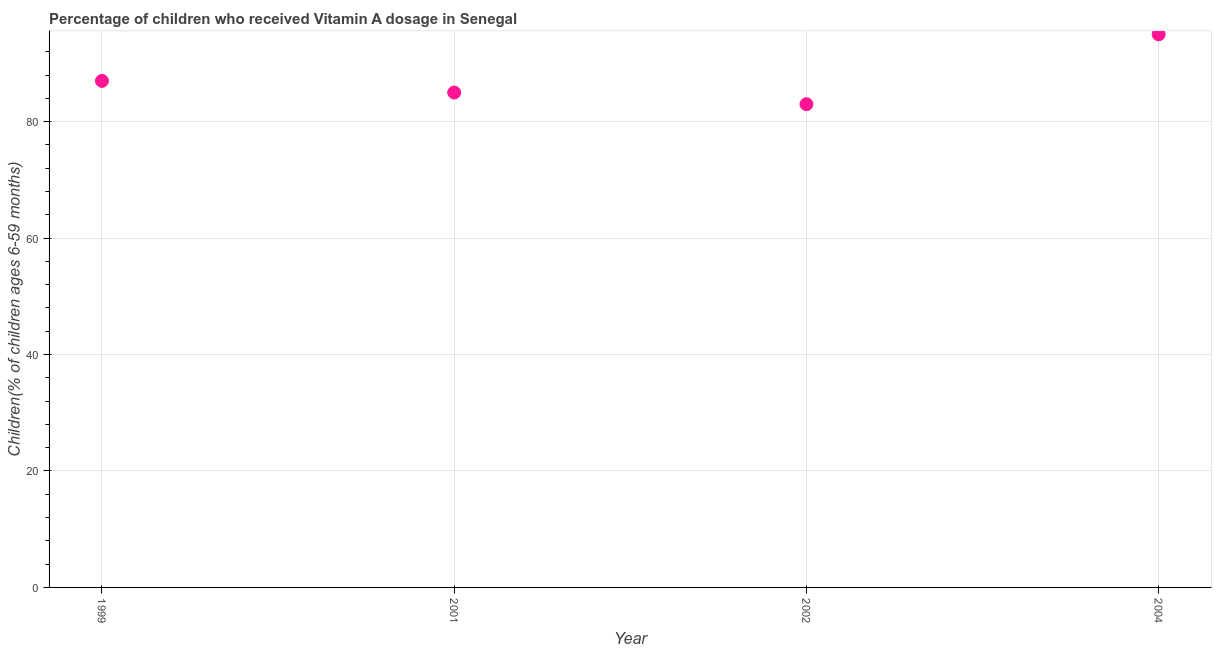What is the vitamin a supplementation coverage rate in 2001?
Make the answer very short. 85. Across all years, what is the maximum vitamin a supplementation coverage rate?
Ensure brevity in your answer.  95. Across all years, what is the minimum vitamin a supplementation coverage rate?
Give a very brief answer. 83. In which year was the vitamin a supplementation coverage rate maximum?
Provide a short and direct response. 2004. In which year was the vitamin a supplementation coverage rate minimum?
Your answer should be compact. 2002. What is the sum of the vitamin a supplementation coverage rate?
Give a very brief answer. 350. What is the difference between the vitamin a supplementation coverage rate in 2001 and 2004?
Offer a terse response. -10. What is the average vitamin a supplementation coverage rate per year?
Keep it short and to the point. 87.5. In how many years, is the vitamin a supplementation coverage rate greater than 76 %?
Offer a very short reply. 4. Do a majority of the years between 2004 and 2002 (inclusive) have vitamin a supplementation coverage rate greater than 84 %?
Ensure brevity in your answer.  No. What is the ratio of the vitamin a supplementation coverage rate in 1999 to that in 2004?
Your answer should be very brief. 0.92. What is the difference between the highest and the second highest vitamin a supplementation coverage rate?
Your response must be concise. 8. What is the difference between the highest and the lowest vitamin a supplementation coverage rate?
Your answer should be compact. 12. In how many years, is the vitamin a supplementation coverage rate greater than the average vitamin a supplementation coverage rate taken over all years?
Make the answer very short. 1. Does the vitamin a supplementation coverage rate monotonically increase over the years?
Keep it short and to the point. No. How many dotlines are there?
Ensure brevity in your answer.  1. What is the difference between two consecutive major ticks on the Y-axis?
Offer a very short reply. 20. Does the graph contain grids?
Give a very brief answer. Yes. What is the title of the graph?
Offer a very short reply. Percentage of children who received Vitamin A dosage in Senegal. What is the label or title of the Y-axis?
Your answer should be very brief. Children(% of children ages 6-59 months). What is the Children(% of children ages 6-59 months) in 2004?
Give a very brief answer. 95. What is the difference between the Children(% of children ages 6-59 months) in 1999 and 2001?
Your response must be concise. 2. What is the difference between the Children(% of children ages 6-59 months) in 1999 and 2002?
Provide a short and direct response. 4. What is the difference between the Children(% of children ages 6-59 months) in 2001 and 2004?
Your answer should be very brief. -10. What is the ratio of the Children(% of children ages 6-59 months) in 1999 to that in 2001?
Keep it short and to the point. 1.02. What is the ratio of the Children(% of children ages 6-59 months) in 1999 to that in 2002?
Provide a succinct answer. 1.05. What is the ratio of the Children(% of children ages 6-59 months) in 1999 to that in 2004?
Keep it short and to the point. 0.92. What is the ratio of the Children(% of children ages 6-59 months) in 2001 to that in 2004?
Provide a short and direct response. 0.9. What is the ratio of the Children(% of children ages 6-59 months) in 2002 to that in 2004?
Offer a very short reply. 0.87. 